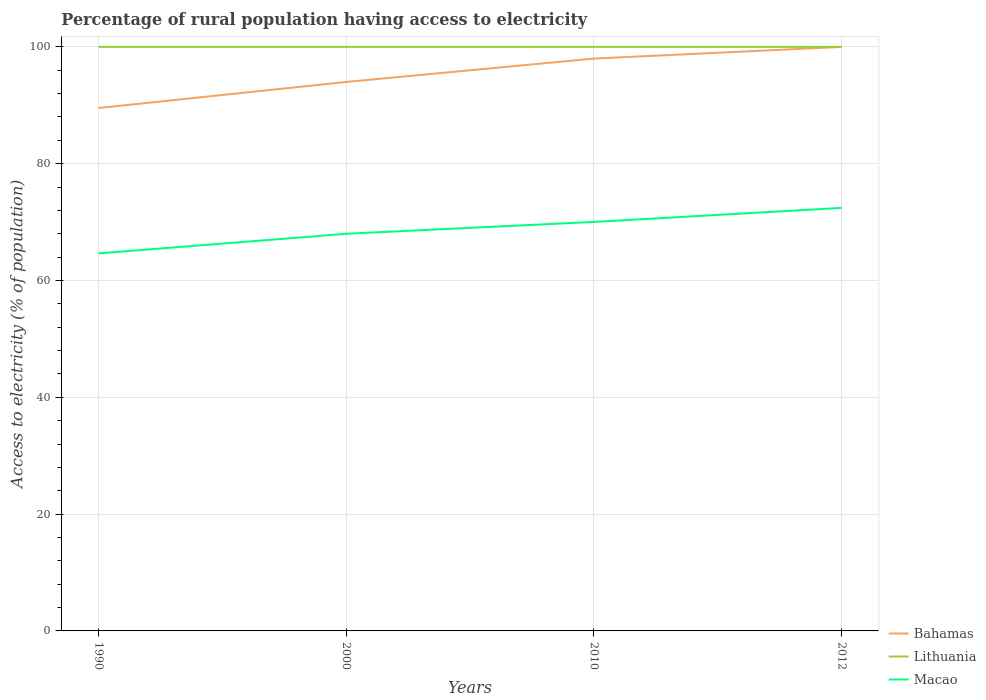Does the line corresponding to Bahamas intersect with the line corresponding to Macao?
Ensure brevity in your answer.  No. Across all years, what is the maximum percentage of rural population having access to electricity in Lithuania?
Provide a short and direct response. 100. What is the total percentage of rural population having access to electricity in Lithuania in the graph?
Offer a very short reply. 0. What is the difference between the highest and the second highest percentage of rural population having access to electricity in Macao?
Provide a succinct answer. 7.79. What is the difference between the highest and the lowest percentage of rural population having access to electricity in Macao?
Provide a short and direct response. 2. How many years are there in the graph?
Ensure brevity in your answer.  4. Are the values on the major ticks of Y-axis written in scientific E-notation?
Provide a short and direct response. No. Does the graph contain any zero values?
Make the answer very short. No. How many legend labels are there?
Provide a short and direct response. 3. What is the title of the graph?
Make the answer very short. Percentage of rural population having access to electricity. Does "Northern Mariana Islands" appear as one of the legend labels in the graph?
Provide a short and direct response. No. What is the label or title of the X-axis?
Your answer should be very brief. Years. What is the label or title of the Y-axis?
Your answer should be compact. Access to electricity (% of population). What is the Access to electricity (% of population) of Bahamas in 1990?
Offer a very short reply. 89.53. What is the Access to electricity (% of population) of Lithuania in 1990?
Your answer should be compact. 100. What is the Access to electricity (% of population) in Macao in 1990?
Offer a very short reply. 64.64. What is the Access to electricity (% of population) in Bahamas in 2000?
Ensure brevity in your answer.  94. What is the Access to electricity (% of population) in Lithuania in 2000?
Provide a short and direct response. 100. What is the Access to electricity (% of population) in Macao in 2000?
Make the answer very short. 68. What is the Access to electricity (% of population) in Lithuania in 2010?
Make the answer very short. 100. What is the Access to electricity (% of population) in Macao in 2010?
Your answer should be compact. 70.03. What is the Access to electricity (% of population) in Macao in 2012?
Offer a terse response. 72.43. Across all years, what is the maximum Access to electricity (% of population) of Bahamas?
Keep it short and to the point. 100. Across all years, what is the maximum Access to electricity (% of population) of Lithuania?
Offer a terse response. 100. Across all years, what is the maximum Access to electricity (% of population) in Macao?
Offer a terse response. 72.43. Across all years, what is the minimum Access to electricity (% of population) of Bahamas?
Keep it short and to the point. 89.53. Across all years, what is the minimum Access to electricity (% of population) of Macao?
Provide a short and direct response. 64.64. What is the total Access to electricity (% of population) in Bahamas in the graph?
Make the answer very short. 381.53. What is the total Access to electricity (% of population) of Macao in the graph?
Provide a short and direct response. 275.11. What is the difference between the Access to electricity (% of population) in Bahamas in 1990 and that in 2000?
Your response must be concise. -4.47. What is the difference between the Access to electricity (% of population) of Macao in 1990 and that in 2000?
Ensure brevity in your answer.  -3.36. What is the difference between the Access to electricity (% of population) of Bahamas in 1990 and that in 2010?
Offer a very short reply. -8.47. What is the difference between the Access to electricity (% of population) of Macao in 1990 and that in 2010?
Your answer should be compact. -5.39. What is the difference between the Access to electricity (% of population) of Bahamas in 1990 and that in 2012?
Keep it short and to the point. -10.47. What is the difference between the Access to electricity (% of population) of Lithuania in 1990 and that in 2012?
Give a very brief answer. 0. What is the difference between the Access to electricity (% of population) in Macao in 1990 and that in 2012?
Your response must be concise. -7.79. What is the difference between the Access to electricity (% of population) of Bahamas in 2000 and that in 2010?
Your response must be concise. -4. What is the difference between the Access to electricity (% of population) of Macao in 2000 and that in 2010?
Your answer should be very brief. -2.03. What is the difference between the Access to electricity (% of population) of Lithuania in 2000 and that in 2012?
Your answer should be very brief. 0. What is the difference between the Access to electricity (% of population) in Macao in 2000 and that in 2012?
Offer a terse response. -4.43. What is the difference between the Access to electricity (% of population) of Bahamas in 2010 and that in 2012?
Your answer should be compact. -2. What is the difference between the Access to electricity (% of population) in Lithuania in 2010 and that in 2012?
Your answer should be very brief. 0. What is the difference between the Access to electricity (% of population) in Macao in 2010 and that in 2012?
Offer a terse response. -2.4. What is the difference between the Access to electricity (% of population) of Bahamas in 1990 and the Access to electricity (% of population) of Lithuania in 2000?
Give a very brief answer. -10.47. What is the difference between the Access to electricity (% of population) in Bahamas in 1990 and the Access to electricity (% of population) in Macao in 2000?
Your answer should be very brief. 21.53. What is the difference between the Access to electricity (% of population) in Bahamas in 1990 and the Access to electricity (% of population) in Lithuania in 2010?
Offer a very short reply. -10.47. What is the difference between the Access to electricity (% of population) in Bahamas in 1990 and the Access to electricity (% of population) in Macao in 2010?
Your response must be concise. 19.5. What is the difference between the Access to electricity (% of population) of Lithuania in 1990 and the Access to electricity (% of population) of Macao in 2010?
Provide a succinct answer. 29.97. What is the difference between the Access to electricity (% of population) of Bahamas in 1990 and the Access to electricity (% of population) of Lithuania in 2012?
Offer a terse response. -10.47. What is the difference between the Access to electricity (% of population) in Bahamas in 1990 and the Access to electricity (% of population) in Macao in 2012?
Your answer should be compact. 17.1. What is the difference between the Access to electricity (% of population) in Lithuania in 1990 and the Access to electricity (% of population) in Macao in 2012?
Provide a short and direct response. 27.57. What is the difference between the Access to electricity (% of population) of Bahamas in 2000 and the Access to electricity (% of population) of Lithuania in 2010?
Provide a succinct answer. -6. What is the difference between the Access to electricity (% of population) in Bahamas in 2000 and the Access to electricity (% of population) in Macao in 2010?
Your response must be concise. 23.97. What is the difference between the Access to electricity (% of population) of Lithuania in 2000 and the Access to electricity (% of population) of Macao in 2010?
Offer a terse response. 29.97. What is the difference between the Access to electricity (% of population) of Bahamas in 2000 and the Access to electricity (% of population) of Macao in 2012?
Offer a terse response. 21.57. What is the difference between the Access to electricity (% of population) in Lithuania in 2000 and the Access to electricity (% of population) in Macao in 2012?
Offer a very short reply. 27.57. What is the difference between the Access to electricity (% of population) of Bahamas in 2010 and the Access to electricity (% of population) of Lithuania in 2012?
Offer a terse response. -2. What is the difference between the Access to electricity (% of population) of Bahamas in 2010 and the Access to electricity (% of population) of Macao in 2012?
Offer a very short reply. 25.57. What is the difference between the Access to electricity (% of population) in Lithuania in 2010 and the Access to electricity (% of population) in Macao in 2012?
Keep it short and to the point. 27.57. What is the average Access to electricity (% of population) in Bahamas per year?
Your response must be concise. 95.38. What is the average Access to electricity (% of population) of Lithuania per year?
Make the answer very short. 100. What is the average Access to electricity (% of population) of Macao per year?
Give a very brief answer. 68.78. In the year 1990, what is the difference between the Access to electricity (% of population) in Bahamas and Access to electricity (% of population) in Lithuania?
Provide a succinct answer. -10.47. In the year 1990, what is the difference between the Access to electricity (% of population) in Bahamas and Access to electricity (% of population) in Macao?
Ensure brevity in your answer.  24.89. In the year 1990, what is the difference between the Access to electricity (% of population) in Lithuania and Access to electricity (% of population) in Macao?
Provide a succinct answer. 35.36. In the year 2010, what is the difference between the Access to electricity (% of population) in Bahamas and Access to electricity (% of population) in Macao?
Ensure brevity in your answer.  27.97. In the year 2010, what is the difference between the Access to electricity (% of population) of Lithuania and Access to electricity (% of population) of Macao?
Provide a short and direct response. 29.97. In the year 2012, what is the difference between the Access to electricity (% of population) of Bahamas and Access to electricity (% of population) of Macao?
Your answer should be very brief. 27.57. In the year 2012, what is the difference between the Access to electricity (% of population) in Lithuania and Access to electricity (% of population) in Macao?
Offer a very short reply. 27.57. What is the ratio of the Access to electricity (% of population) of Bahamas in 1990 to that in 2000?
Your answer should be very brief. 0.95. What is the ratio of the Access to electricity (% of population) of Lithuania in 1990 to that in 2000?
Give a very brief answer. 1. What is the ratio of the Access to electricity (% of population) of Macao in 1990 to that in 2000?
Give a very brief answer. 0.95. What is the ratio of the Access to electricity (% of population) of Bahamas in 1990 to that in 2010?
Keep it short and to the point. 0.91. What is the ratio of the Access to electricity (% of population) in Lithuania in 1990 to that in 2010?
Give a very brief answer. 1. What is the ratio of the Access to electricity (% of population) in Macao in 1990 to that in 2010?
Ensure brevity in your answer.  0.92. What is the ratio of the Access to electricity (% of population) in Bahamas in 1990 to that in 2012?
Provide a short and direct response. 0.9. What is the ratio of the Access to electricity (% of population) of Lithuania in 1990 to that in 2012?
Provide a succinct answer. 1. What is the ratio of the Access to electricity (% of population) in Macao in 1990 to that in 2012?
Provide a short and direct response. 0.89. What is the ratio of the Access to electricity (% of population) in Bahamas in 2000 to that in 2010?
Ensure brevity in your answer.  0.96. What is the ratio of the Access to electricity (% of population) of Bahamas in 2000 to that in 2012?
Your answer should be compact. 0.94. What is the ratio of the Access to electricity (% of population) of Macao in 2000 to that in 2012?
Your answer should be very brief. 0.94. What is the ratio of the Access to electricity (% of population) of Lithuania in 2010 to that in 2012?
Your answer should be very brief. 1. What is the ratio of the Access to electricity (% of population) in Macao in 2010 to that in 2012?
Offer a very short reply. 0.97. What is the difference between the highest and the second highest Access to electricity (% of population) in Bahamas?
Your answer should be very brief. 2. What is the difference between the highest and the second highest Access to electricity (% of population) in Macao?
Make the answer very short. 2.4. What is the difference between the highest and the lowest Access to electricity (% of population) of Bahamas?
Make the answer very short. 10.47. What is the difference between the highest and the lowest Access to electricity (% of population) of Lithuania?
Offer a very short reply. 0. What is the difference between the highest and the lowest Access to electricity (% of population) of Macao?
Offer a very short reply. 7.79. 